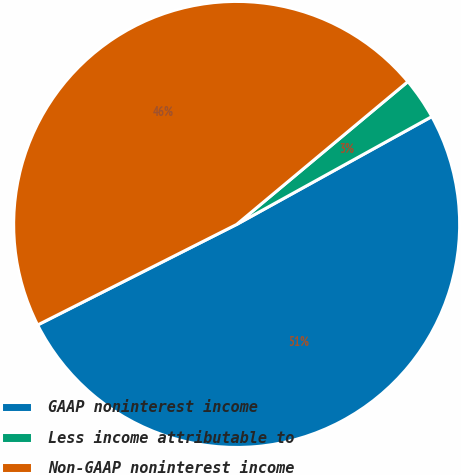Convert chart. <chart><loc_0><loc_0><loc_500><loc_500><pie_chart><fcel>GAAP noninterest income<fcel>Less income attributable to<fcel>Non-GAAP noninterest income<nl><fcel>50.59%<fcel>3.03%<fcel>46.38%<nl></chart> 